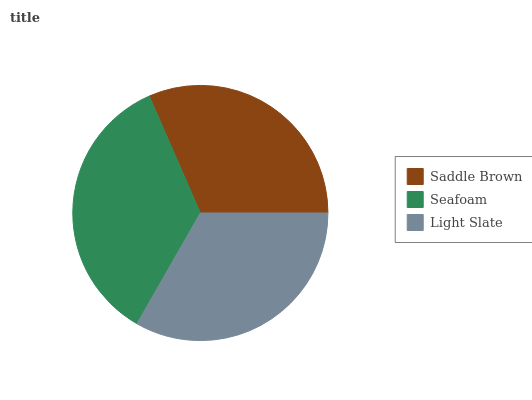Is Saddle Brown the minimum?
Answer yes or no. Yes. Is Seafoam the maximum?
Answer yes or no. Yes. Is Light Slate the minimum?
Answer yes or no. No. Is Light Slate the maximum?
Answer yes or no. No. Is Seafoam greater than Light Slate?
Answer yes or no. Yes. Is Light Slate less than Seafoam?
Answer yes or no. Yes. Is Light Slate greater than Seafoam?
Answer yes or no. No. Is Seafoam less than Light Slate?
Answer yes or no. No. Is Light Slate the high median?
Answer yes or no. Yes. Is Light Slate the low median?
Answer yes or no. Yes. Is Saddle Brown the high median?
Answer yes or no. No. Is Seafoam the low median?
Answer yes or no. No. 